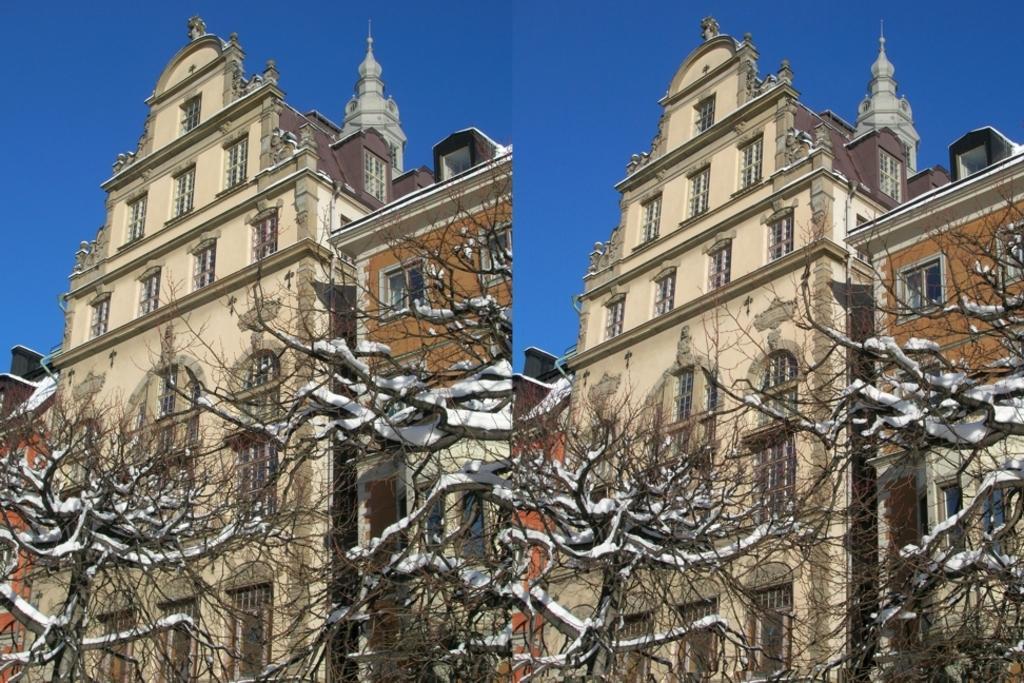In one or two sentences, can you explain what this image depicts? This picture is a collage of two images. We can observe trees and cream color building in the two images. There is some snow on the trees. In the background there is a sky. 